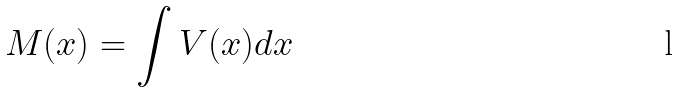<formula> <loc_0><loc_0><loc_500><loc_500>M ( x ) = \int V ( x ) d x</formula> 